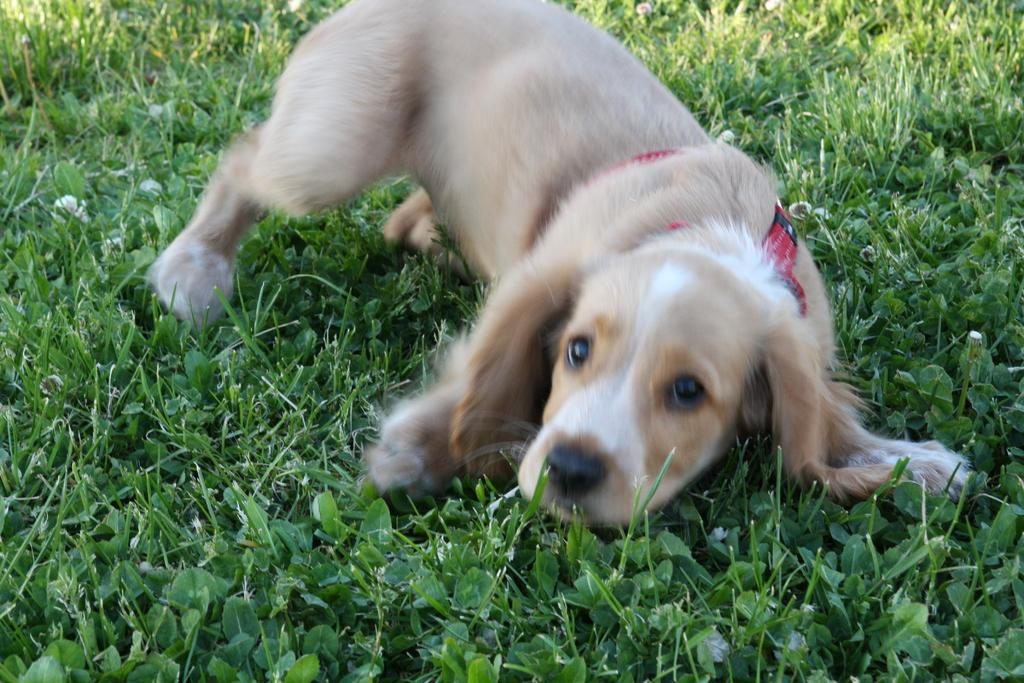What type of creature is in the image? There is an animal in the image. Can you describe the color of the animal? The animal has a white and cream color. What is the color of the grass in the image? The grass in the image is green. How many books can be seen on the animal's back in the image? There are no books present in the image, as it features an animal with a white and cream color on green grass. 